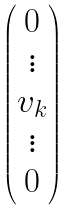<formula> <loc_0><loc_0><loc_500><loc_500>\begin{pmatrix} 0 \\ \vdots \\ v _ { k } \\ \vdots \\ 0 \end{pmatrix}</formula> 